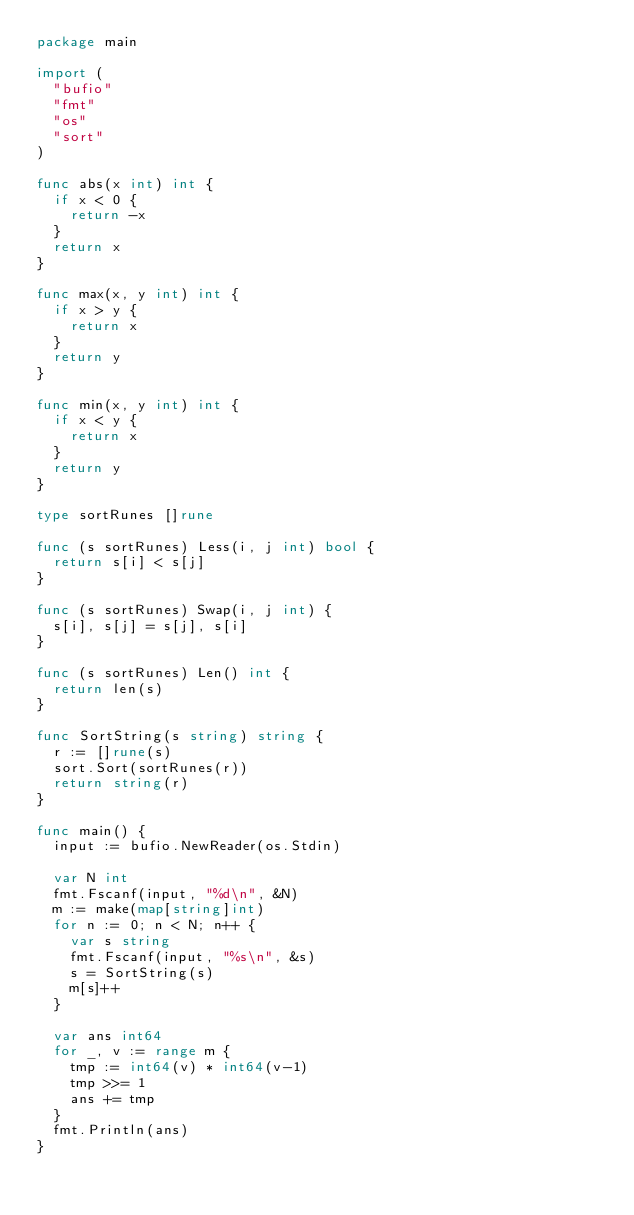<code> <loc_0><loc_0><loc_500><loc_500><_Go_>package main

import (
	"bufio"
	"fmt"
	"os"
	"sort"
)

func abs(x int) int {
	if x < 0 {
		return -x
	}
	return x
}

func max(x, y int) int {
	if x > y {
		return x
	}
	return y
}

func min(x, y int) int {
	if x < y {
		return x
	}
	return y
}

type sortRunes []rune

func (s sortRunes) Less(i, j int) bool {
	return s[i] < s[j]
}

func (s sortRunes) Swap(i, j int) {
	s[i], s[j] = s[j], s[i]
}

func (s sortRunes) Len() int {
	return len(s)
}

func SortString(s string) string {
	r := []rune(s)
	sort.Sort(sortRunes(r))
	return string(r)
}

func main() {
	input := bufio.NewReader(os.Stdin)

	var N int
	fmt.Fscanf(input, "%d\n", &N)
	m := make(map[string]int)
	for n := 0; n < N; n++ {
		var s string
		fmt.Fscanf(input, "%s\n", &s)
		s = SortString(s)
		m[s]++
	}

	var ans int64
	for _, v := range m {
		tmp := int64(v) * int64(v-1)
		tmp >>= 1
		ans += tmp
	}
	fmt.Println(ans)
}
</code> 